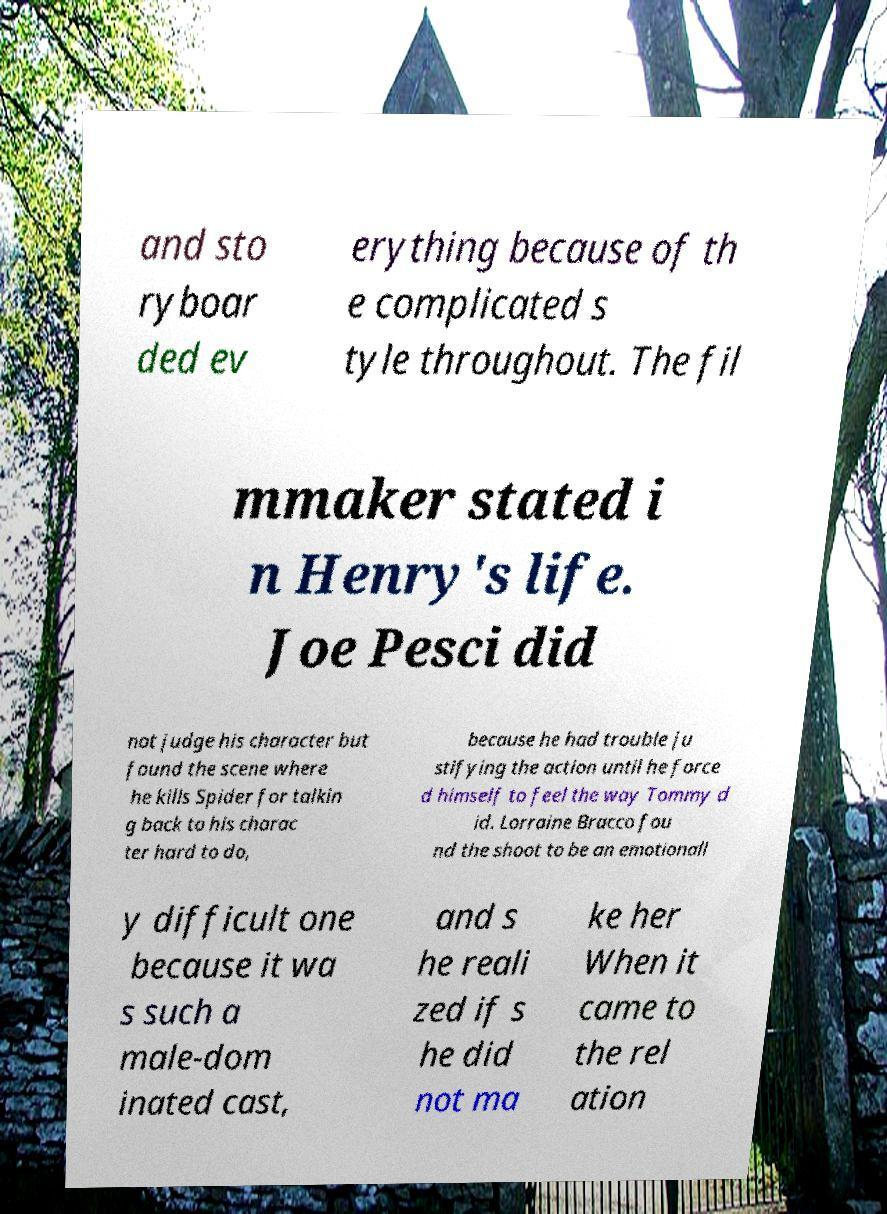For documentation purposes, I need the text within this image transcribed. Could you provide that? and sto ryboar ded ev erything because of th e complicated s tyle throughout. The fil mmaker stated i n Henry's life. Joe Pesci did not judge his character but found the scene where he kills Spider for talkin g back to his charac ter hard to do, because he had trouble ju stifying the action until he force d himself to feel the way Tommy d id. Lorraine Bracco fou nd the shoot to be an emotionall y difficult one because it wa s such a male-dom inated cast, and s he reali zed if s he did not ma ke her When it came to the rel ation 